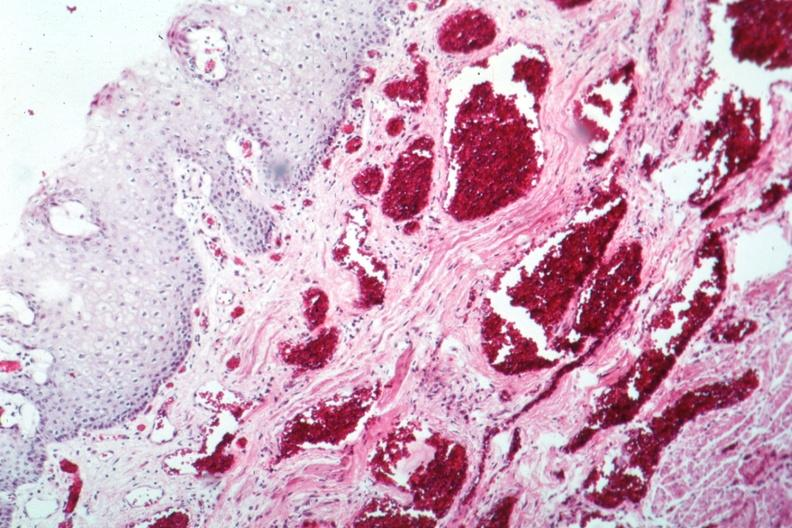s slices of liver and spleen typical tuberculous exudate is present on capsule of liver and spleen present?
Answer the question using a single word or phrase. No 